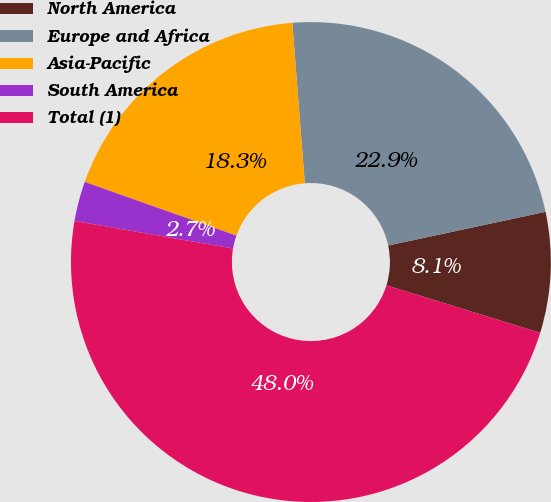Convert chart. <chart><loc_0><loc_0><loc_500><loc_500><pie_chart><fcel>North America<fcel>Europe and Africa<fcel>Asia-Pacific<fcel>South America<fcel>Total (1)<nl><fcel>8.12%<fcel>22.88%<fcel>18.35%<fcel>2.68%<fcel>47.98%<nl></chart> 